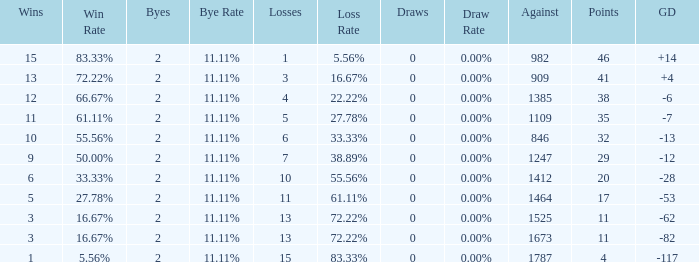What is the number listed under against when there were less than 13 losses and less than 2 byes? 0.0. 